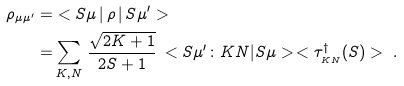Convert formula to latex. <formula><loc_0><loc_0><loc_500><loc_500>\rho _ { \mu \mu ^ { \prime } } = & < S \mu \, | \, \rho \, | \, S \mu ^ { \prime } > \\ = & \sum _ { K , N } \, \frac { \sqrt { 2 K + 1 } } { 2 S + 1 } \, < S \mu ^ { \prime } \colon K N | S \mu > \, < \tau _ { _ { K N } } ^ { \dagger } ( S ) > \ .</formula> 